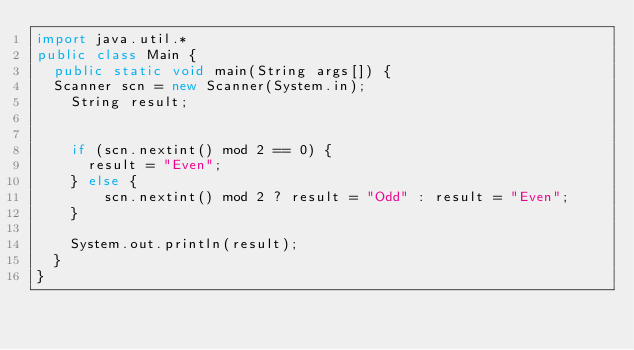<code> <loc_0><loc_0><loc_500><loc_500><_Java_>import java.util.*
public class Main {
  public static void main(String args[]) {
	Scanner scn = new Scanner(System.in);
    String result;
    
    
    if (scn.nextint() mod 2 == 0) {
    	result = "Even";
    } else {
        scn.nextint() mod 2 ? result = "Odd" : result = "Even";
    }
    
    System.out.println(result);
  }
}
</code> 